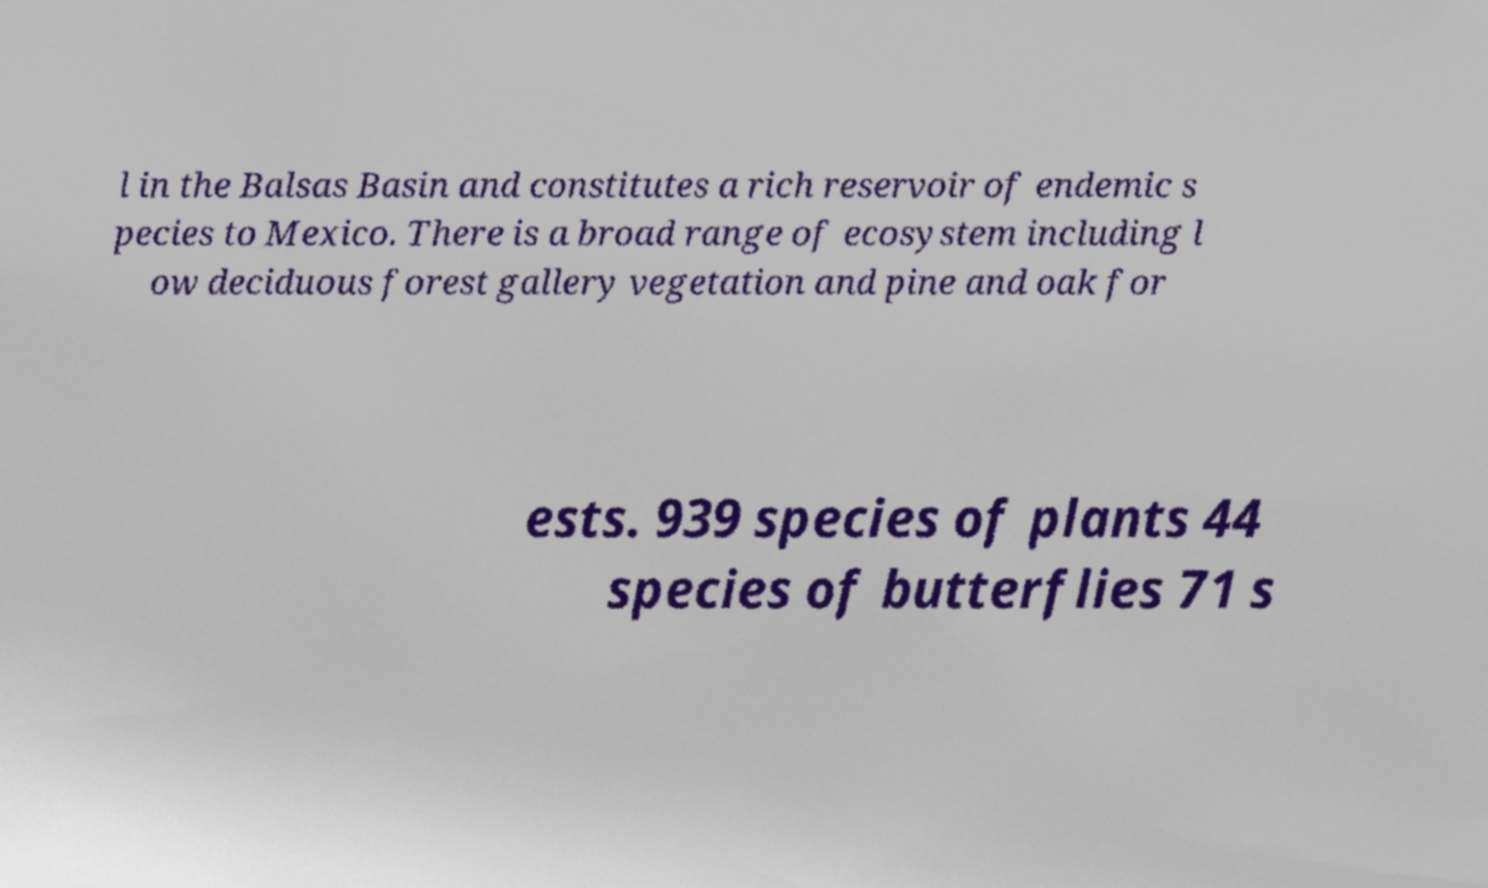For documentation purposes, I need the text within this image transcribed. Could you provide that? l in the Balsas Basin and constitutes a rich reservoir of endemic s pecies to Mexico. There is a broad range of ecosystem including l ow deciduous forest gallery vegetation and pine and oak for ests. 939 species of plants 44 species of butterflies 71 s 